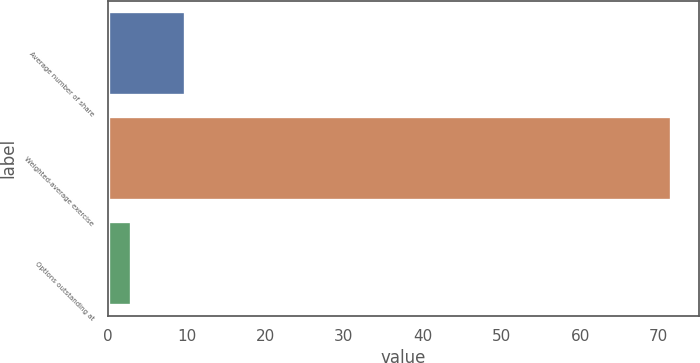Convert chart to OTSL. <chart><loc_0><loc_0><loc_500><loc_500><bar_chart><fcel>Average number of share<fcel>Weighted-average exercise<fcel>Options outstanding at<nl><fcel>9.85<fcel>71.49<fcel>3<nl></chart> 